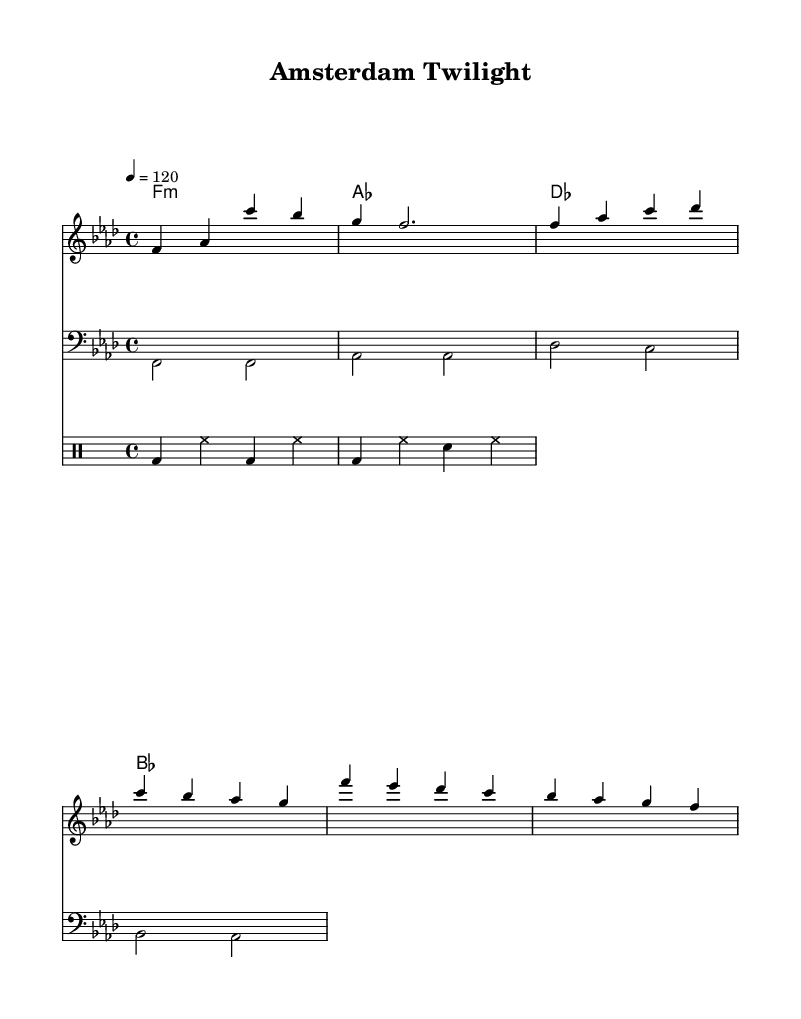What is the key signature of this music? The key signature indicates how many sharps or flats are in the piece. In this music, the key is F minor, which has four flats (B♭, E♭, A♭, and D♭), visible in the key signature at the beginning of the sheet.
Answer: F minor What is the time signature of this music? The time signature is indicated at the beginning of the sheet music. Here, it shows 4/4, meaning there are four beats in each measure, and the quarter note gets one beat.
Answer: 4/4 What is the tempo marking for the piece? The tempo marking is shown at the beginning as "4 = 120," meaning that there are 120 beats per minute, setting the pace for the performance of the piece.
Answer: 120 How many measures are in the melody section? To determine the number of measures, we count each set of vertical bar lines in the melody staff. There are four measures in the melody part presented in this score.
Answer: 4 Which section contains the chords and what are they? Chords are provided in a separate staff labeled "ChordNames". The chords indicated throughout the piece are: F minor, A♭ major, D♭ major, and B♭ major.
Answer: F minor, A♭ major, D♭ major, B♭ major What type of rhythm is primarily used in the drums section? The drum section uses a repetitive pattern with kick drums, hi-hats, and snare arranged rhythmically. The bass drum is used on the beats, with hi-hats accompanying to create a driving rhythm typical of house music.
Answer: Repetitive pattern 